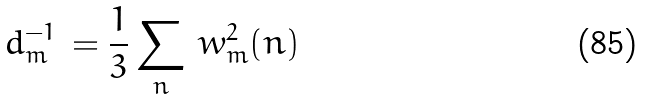Convert formula to latex. <formula><loc_0><loc_0><loc_500><loc_500>d _ { m } ^ { - 1 } \, = \frac { 1 } { 3 } \sum _ { n } \, w ^ { 2 } _ { m } ( n )</formula> 